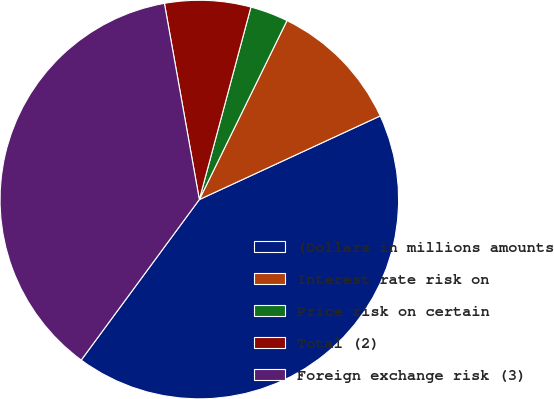Convert chart. <chart><loc_0><loc_0><loc_500><loc_500><pie_chart><fcel>(Dollars in millions amounts<fcel>Interest rate risk on<fcel>Price risk on certain<fcel>Total (2)<fcel>Foreign exchange risk (3)<nl><fcel>41.99%<fcel>10.86%<fcel>3.08%<fcel>6.97%<fcel>37.1%<nl></chart> 